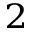Convert formula to latex. <formula><loc_0><loc_0><loc_500><loc_500>^ { 2 }</formula> 